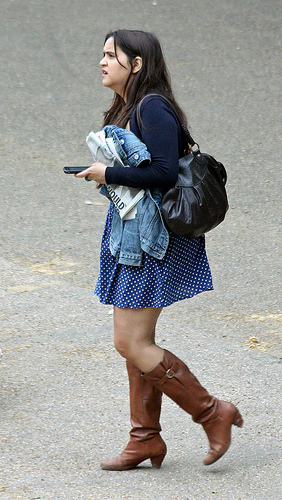What time of year does this scene appear to represent? Based on the attire of the person in the image, with a light jacket and a skirt, it appears to be during a temperate season, likely spring or fall. 